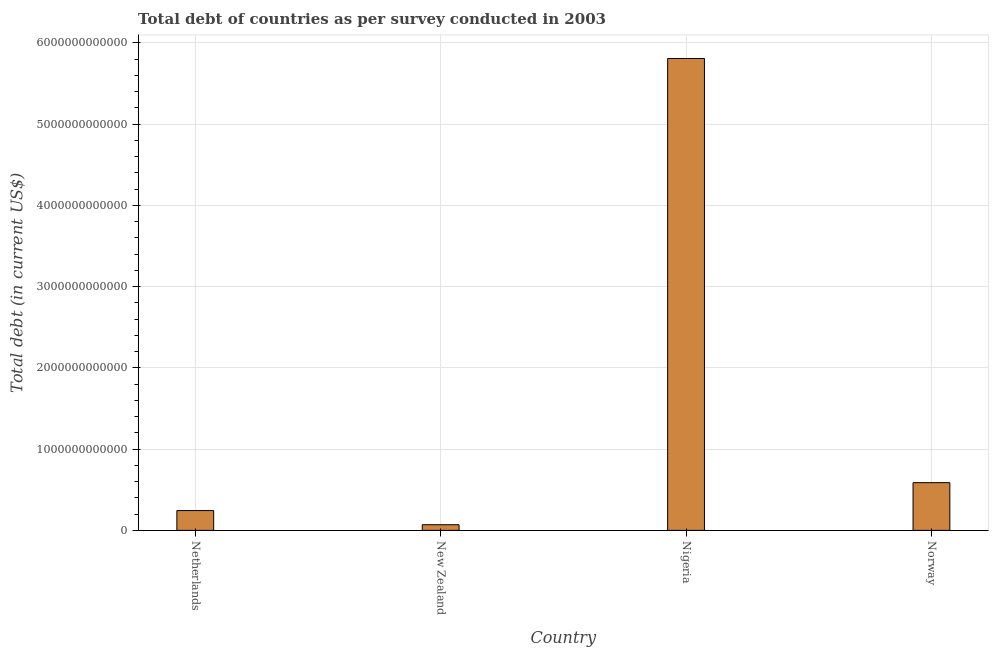Does the graph contain grids?
Offer a very short reply. Yes. What is the title of the graph?
Your answer should be very brief. Total debt of countries as per survey conducted in 2003. What is the label or title of the X-axis?
Provide a short and direct response. Country. What is the label or title of the Y-axis?
Keep it short and to the point. Total debt (in current US$). What is the total debt in Norway?
Give a very brief answer. 5.87e+11. Across all countries, what is the maximum total debt?
Make the answer very short. 5.81e+12. Across all countries, what is the minimum total debt?
Your answer should be compact. 6.97e+1. In which country was the total debt maximum?
Give a very brief answer. Nigeria. In which country was the total debt minimum?
Your response must be concise. New Zealand. What is the sum of the total debt?
Offer a very short reply. 6.71e+12. What is the difference between the total debt in Nigeria and Norway?
Your response must be concise. 5.22e+12. What is the average total debt per country?
Provide a succinct answer. 1.68e+12. What is the median total debt?
Ensure brevity in your answer.  4.16e+11. What is the ratio of the total debt in Netherlands to that in Norway?
Provide a short and direct response. 0.41. Is the difference between the total debt in Netherlands and Nigeria greater than the difference between any two countries?
Your response must be concise. No. What is the difference between the highest and the second highest total debt?
Your answer should be very brief. 5.22e+12. Is the sum of the total debt in New Zealand and Nigeria greater than the maximum total debt across all countries?
Provide a succinct answer. Yes. What is the difference between the highest and the lowest total debt?
Make the answer very short. 5.74e+12. In how many countries, is the total debt greater than the average total debt taken over all countries?
Offer a very short reply. 1. Are all the bars in the graph horizontal?
Your answer should be compact. No. How many countries are there in the graph?
Ensure brevity in your answer.  4. What is the difference between two consecutive major ticks on the Y-axis?
Your answer should be very brief. 1.00e+12. What is the Total debt (in current US$) of Netherlands?
Provide a short and direct response. 2.44e+11. What is the Total debt (in current US$) of New Zealand?
Ensure brevity in your answer.  6.97e+1. What is the Total debt (in current US$) of Nigeria?
Offer a terse response. 5.81e+12. What is the Total debt (in current US$) of Norway?
Offer a terse response. 5.87e+11. What is the difference between the Total debt (in current US$) in Netherlands and New Zealand?
Ensure brevity in your answer.  1.74e+11. What is the difference between the Total debt (in current US$) in Netherlands and Nigeria?
Offer a terse response. -5.56e+12. What is the difference between the Total debt (in current US$) in Netherlands and Norway?
Provide a short and direct response. -3.44e+11. What is the difference between the Total debt (in current US$) in New Zealand and Nigeria?
Provide a succinct answer. -5.74e+12. What is the difference between the Total debt (in current US$) in New Zealand and Norway?
Your response must be concise. -5.18e+11. What is the difference between the Total debt (in current US$) in Nigeria and Norway?
Provide a succinct answer. 5.22e+12. What is the ratio of the Total debt (in current US$) in Netherlands to that in New Zealand?
Make the answer very short. 3.5. What is the ratio of the Total debt (in current US$) in Netherlands to that in Nigeria?
Make the answer very short. 0.04. What is the ratio of the Total debt (in current US$) in Netherlands to that in Norway?
Provide a short and direct response. 0.41. What is the ratio of the Total debt (in current US$) in New Zealand to that in Nigeria?
Keep it short and to the point. 0.01. What is the ratio of the Total debt (in current US$) in New Zealand to that in Norway?
Your response must be concise. 0.12. What is the ratio of the Total debt (in current US$) in Nigeria to that in Norway?
Offer a very short reply. 9.89. 